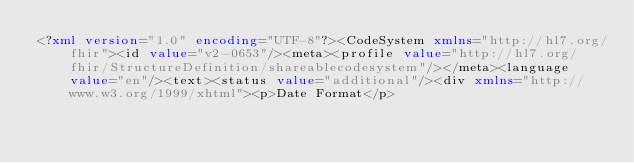<code> <loc_0><loc_0><loc_500><loc_500><_XML_><?xml version="1.0" encoding="UTF-8"?><CodeSystem xmlns="http://hl7.org/fhir"><id value="v2-0653"/><meta><profile value="http://hl7.org/fhir/StructureDefinition/shareablecodesystem"/></meta><language value="en"/><text><status value="additional"/><div xmlns="http://www.w3.org/1999/xhtml"><p>Date Format</p></code> 